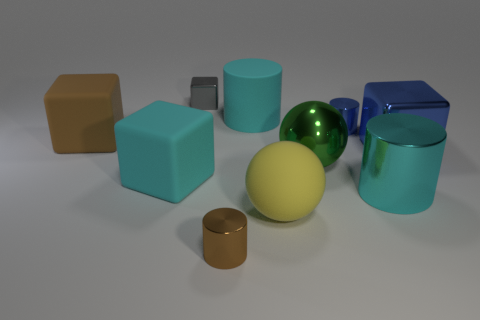How many rubber cylinders are the same color as the large metal cylinder?
Your response must be concise. 1. What material is the other large cylinder that is the same color as the big rubber cylinder?
Provide a short and direct response. Metal. There is a large metallic cylinder; does it have the same color as the large cylinder that is behind the cyan cube?
Your answer should be compact. Yes. Is the color of the large metallic cylinder the same as the big rubber cylinder?
Provide a short and direct response. Yes. There is a brown object to the right of the large block on the left side of the large cyan cube; how many green balls are on the left side of it?
Ensure brevity in your answer.  0. What shape is the blue object that is behind the big block that is right of the block that is behind the tiny blue metal cylinder?
Ensure brevity in your answer.  Cylinder. How many other objects are there of the same color as the rubber cylinder?
Offer a very short reply. 2. What shape is the blue shiny object that is behind the large blue block that is in front of the small block?
Provide a succinct answer. Cylinder. There is a gray metal cube; what number of large cyan matte things are to the left of it?
Provide a succinct answer. 1. Are there any small gray balls made of the same material as the small brown cylinder?
Your response must be concise. No. 